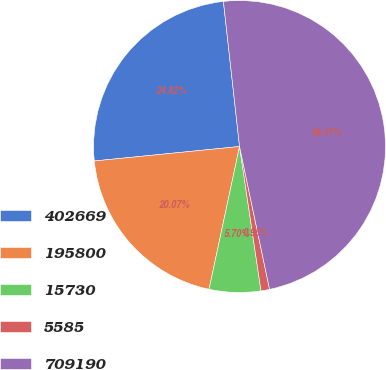Convert chart. <chart><loc_0><loc_0><loc_500><loc_500><pie_chart><fcel>402669<fcel>195800<fcel>15730<fcel>5585<fcel>709190<nl><fcel>24.82%<fcel>20.07%<fcel>5.7%<fcel>0.95%<fcel>48.47%<nl></chart> 